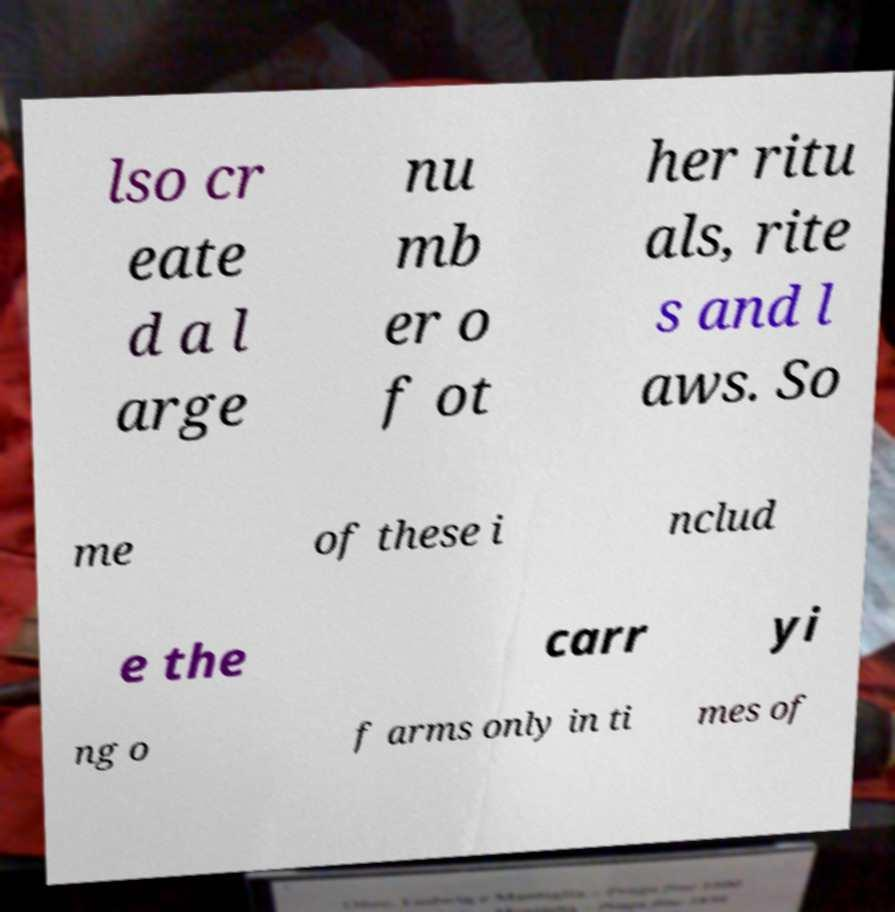Please read and relay the text visible in this image. What does it say? lso cr eate d a l arge nu mb er o f ot her ritu als, rite s and l aws. So me of these i nclud e the carr yi ng o f arms only in ti mes of 